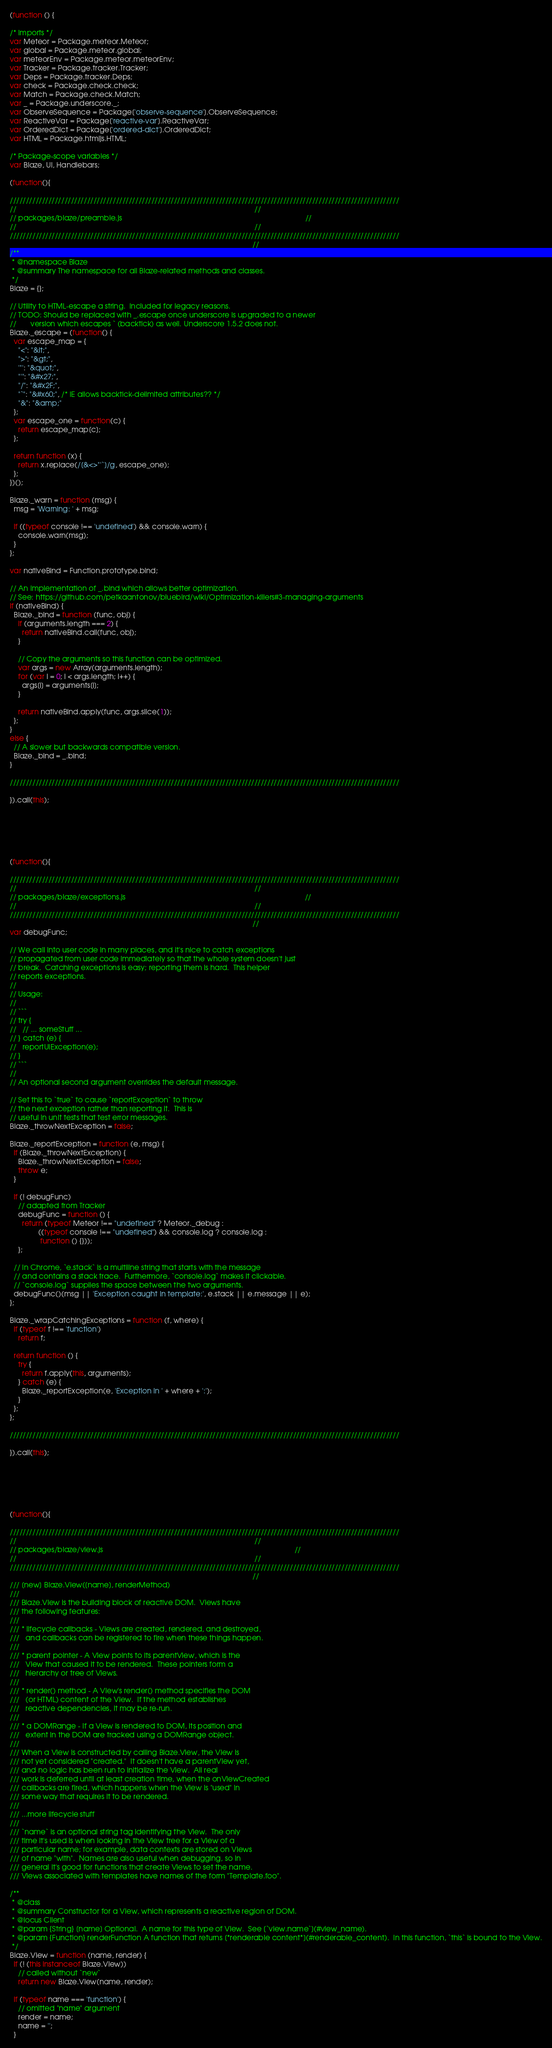<code> <loc_0><loc_0><loc_500><loc_500><_JavaScript_>(function () {

/* Imports */
var Meteor = Package.meteor.Meteor;
var global = Package.meteor.global;
var meteorEnv = Package.meteor.meteorEnv;
var Tracker = Package.tracker.Tracker;
var Deps = Package.tracker.Deps;
var check = Package.check.check;
var Match = Package.check.Match;
var _ = Package.underscore._;
var ObserveSequence = Package['observe-sequence'].ObserveSequence;
var ReactiveVar = Package['reactive-var'].ReactiveVar;
var OrderedDict = Package['ordered-dict'].OrderedDict;
var HTML = Package.htmljs.HTML;

/* Package-scope variables */
var Blaze, UI, Handlebars;

(function(){

/////////////////////////////////////////////////////////////////////////////////////////////////////////////////////////
//                                                                                                                     //
// packages/blaze/preamble.js                                                                                          //
//                                                                                                                     //
/////////////////////////////////////////////////////////////////////////////////////////////////////////////////////////
                                                                                                                       //
/**
 * @namespace Blaze
 * @summary The namespace for all Blaze-related methods and classes.
 */
Blaze = {};

// Utility to HTML-escape a string.  Included for legacy reasons.
// TODO: Should be replaced with _.escape once underscore is upgraded to a newer
//       version which escapes ` (backtick) as well. Underscore 1.5.2 does not.
Blaze._escape = (function() {
  var escape_map = {
    "<": "&lt;",
    ">": "&gt;",
    '"': "&quot;",
    "'": "&#x27;",
    "/": "&#x2F;",
    "`": "&#x60;", /* IE allows backtick-delimited attributes?? */
    "&": "&amp;"
  };
  var escape_one = function(c) {
    return escape_map[c];
  };

  return function (x) {
    return x.replace(/[&<>"'`]/g, escape_one);
  };
})();

Blaze._warn = function (msg) {
  msg = 'Warning: ' + msg;

  if ((typeof console !== 'undefined') && console.warn) {
    console.warn(msg);
  }
};

var nativeBind = Function.prototype.bind;

// An implementation of _.bind which allows better optimization.
// See: https://github.com/petkaantonov/bluebird/wiki/Optimization-killers#3-managing-arguments
if (nativeBind) {
  Blaze._bind = function (func, obj) {
    if (arguments.length === 2) {
      return nativeBind.call(func, obj);
    }

    // Copy the arguments so this function can be optimized.
    var args = new Array(arguments.length);
    for (var i = 0; i < args.length; i++) {
      args[i] = arguments[i];
    }

    return nativeBind.apply(func, args.slice(1));
  };
}
else {
  // A slower but backwards compatible version.
  Blaze._bind = _.bind;
}

/////////////////////////////////////////////////////////////////////////////////////////////////////////////////////////

}).call(this);






(function(){

/////////////////////////////////////////////////////////////////////////////////////////////////////////////////////////
//                                                                                                                     //
// packages/blaze/exceptions.js                                                                                        //
//                                                                                                                     //
/////////////////////////////////////////////////////////////////////////////////////////////////////////////////////////
                                                                                                                       //
var debugFunc;

// We call into user code in many places, and it's nice to catch exceptions
// propagated from user code immediately so that the whole system doesn't just
// break.  Catching exceptions is easy; reporting them is hard.  This helper
// reports exceptions.
//
// Usage:
//
// ```
// try {
//   // ... someStuff ...
// } catch (e) {
//   reportUIException(e);
// }
// ```
//
// An optional second argument overrides the default message.

// Set this to `true` to cause `reportException` to throw
// the next exception rather than reporting it.  This is
// useful in unit tests that test error messages.
Blaze._throwNextException = false;

Blaze._reportException = function (e, msg) {
  if (Blaze._throwNextException) {
    Blaze._throwNextException = false;
    throw e;
  }

  if (! debugFunc)
    // adapted from Tracker
    debugFunc = function () {
      return (typeof Meteor !== "undefined" ? Meteor._debug :
              ((typeof console !== "undefined") && console.log ? console.log :
               function () {}));
    };

  // In Chrome, `e.stack` is a multiline string that starts with the message
  // and contains a stack trace.  Furthermore, `console.log` makes it clickable.
  // `console.log` supplies the space between the two arguments.
  debugFunc()(msg || 'Exception caught in template:', e.stack || e.message || e);
};

Blaze._wrapCatchingExceptions = function (f, where) {
  if (typeof f !== 'function')
    return f;

  return function () {
    try {
      return f.apply(this, arguments);
    } catch (e) {
      Blaze._reportException(e, 'Exception in ' + where + ':');
    }
  };
};

/////////////////////////////////////////////////////////////////////////////////////////////////////////////////////////

}).call(this);






(function(){

/////////////////////////////////////////////////////////////////////////////////////////////////////////////////////////
//                                                                                                                     //
// packages/blaze/view.js                                                                                              //
//                                                                                                                     //
/////////////////////////////////////////////////////////////////////////////////////////////////////////////////////////
                                                                                                                       //
/// [new] Blaze.View([name], renderMethod)
///
/// Blaze.View is the building block of reactive DOM.  Views have
/// the following features:
///
/// * lifecycle callbacks - Views are created, rendered, and destroyed,
///   and callbacks can be registered to fire when these things happen.
///
/// * parent pointer - A View points to its parentView, which is the
///   View that caused it to be rendered.  These pointers form a
///   hierarchy or tree of Views.
///
/// * render() method - A View's render() method specifies the DOM
///   (or HTML) content of the View.  If the method establishes
///   reactive dependencies, it may be re-run.
///
/// * a DOMRange - If a View is rendered to DOM, its position and
///   extent in the DOM are tracked using a DOMRange object.
///
/// When a View is constructed by calling Blaze.View, the View is
/// not yet considered "created."  It doesn't have a parentView yet,
/// and no logic has been run to initialize the View.  All real
/// work is deferred until at least creation time, when the onViewCreated
/// callbacks are fired, which happens when the View is "used" in
/// some way that requires it to be rendered.
///
/// ...more lifecycle stuff
///
/// `name` is an optional string tag identifying the View.  The only
/// time it's used is when looking in the View tree for a View of a
/// particular name; for example, data contexts are stored on Views
/// of name "with".  Names are also useful when debugging, so in
/// general it's good for functions that create Views to set the name.
/// Views associated with templates have names of the form "Template.foo".

/**
 * @class
 * @summary Constructor for a View, which represents a reactive region of DOM.
 * @locus Client
 * @param {String} [name] Optional.  A name for this type of View.  See [`view.name`](#view_name).
 * @param {Function} renderFunction A function that returns [*renderable content*](#renderable_content).  In this function, `this` is bound to the View.
 */
Blaze.View = function (name, render) {
  if (! (this instanceof Blaze.View))
    // called without `new`
    return new Blaze.View(name, render);

  if (typeof name === 'function') {
    // omitted "name" argument
    render = name;
    name = '';
  }</code> 